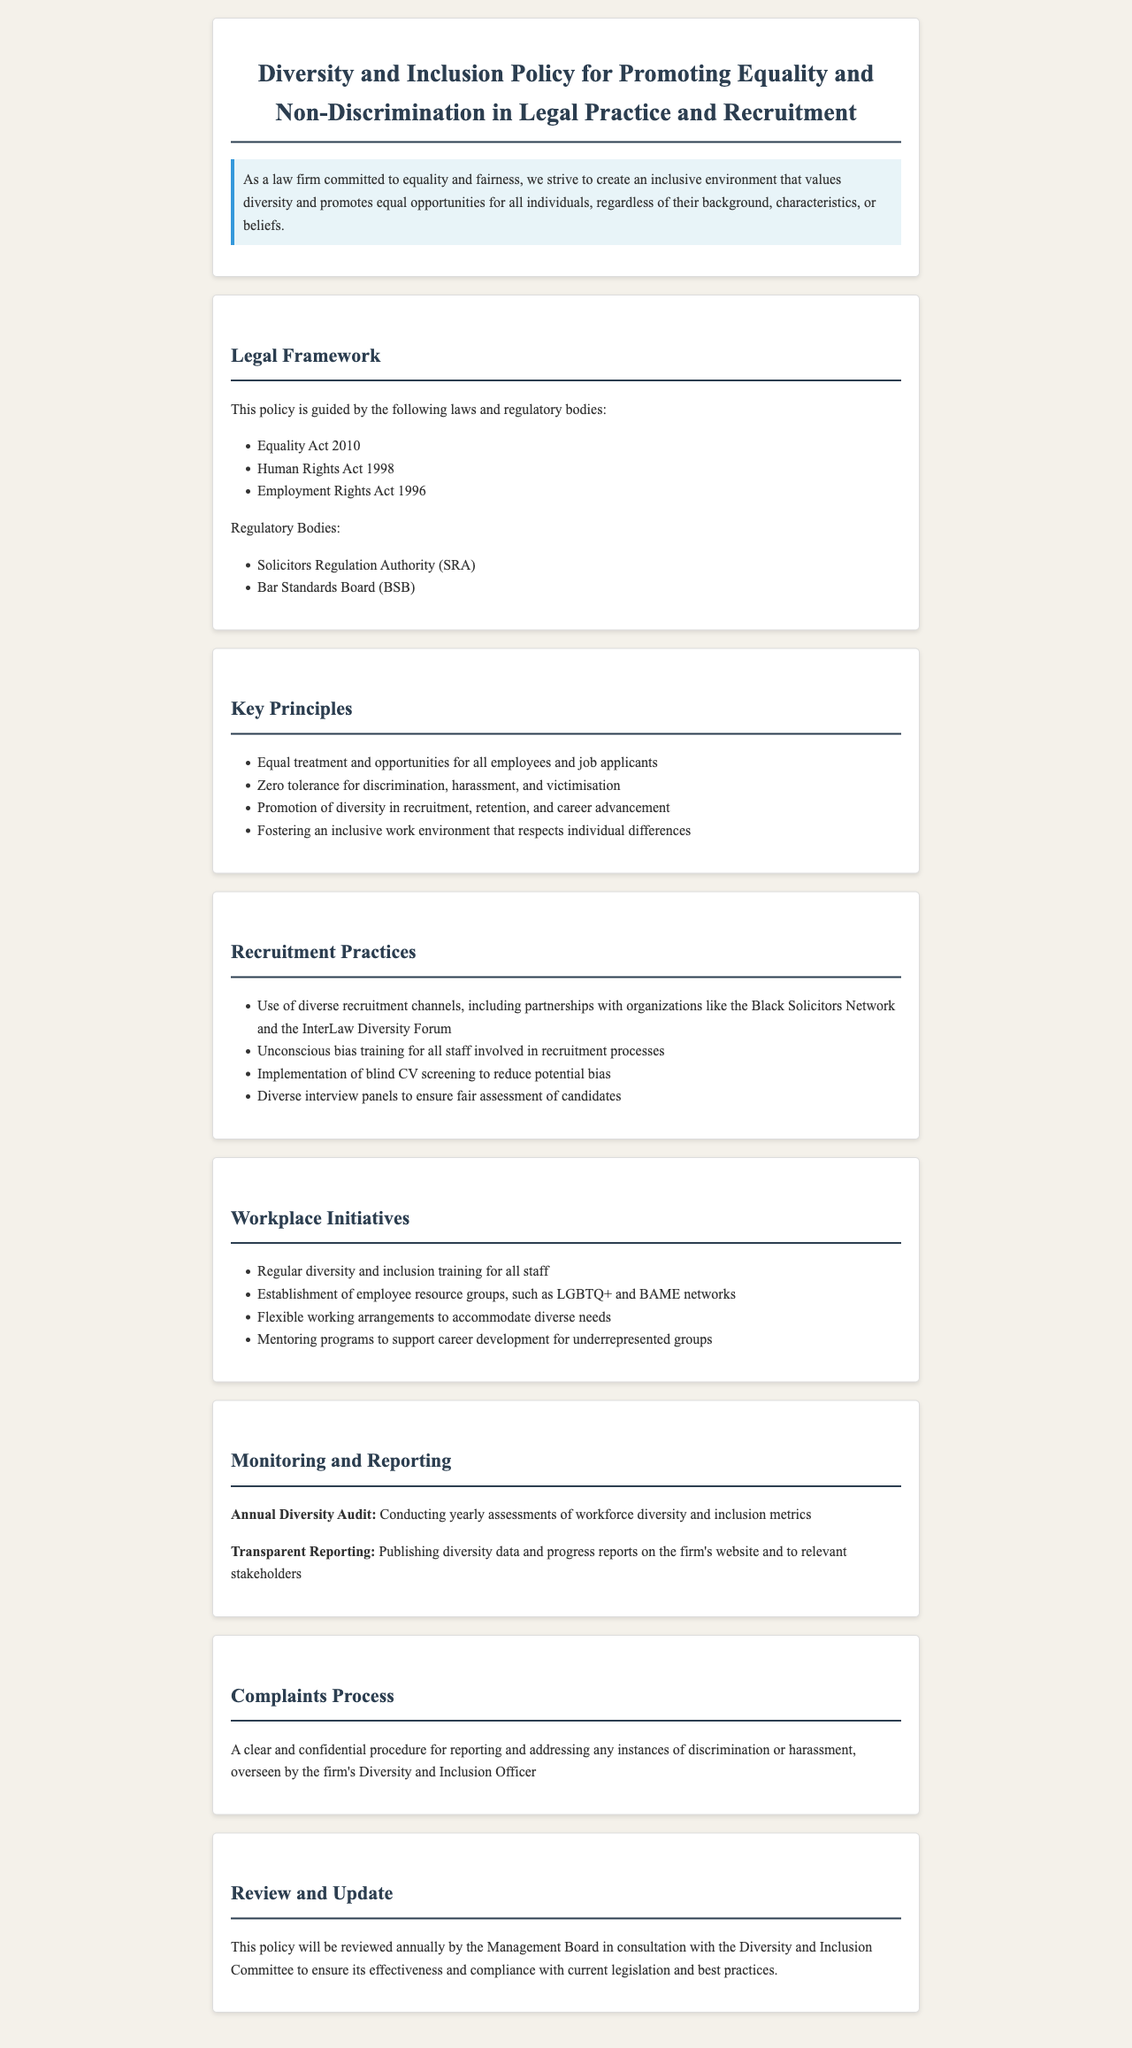What is the title of the policy? The title of the policy outlines its main focus on diversity and inclusion in legal practice and recruitment.
Answer: Diversity and Inclusion Policy for Promoting Equality and Non-Discrimination in Legal Practice and Recruitment Which act is included in the legal framework? This asks for a specific act that supports the policy’s legal background, mentioned under the Legal Framework section.
Answer: Equality Act 2010 What is the zero tolerance policy about? This refers to the principle that emphasizes a firm stance against specific negative behaviors within the workplace as stated in the Key Principles section.
Answer: Discrimination, harassment, and victimisation What recruitment practice is used to reduce potential bias? This question seeks a specific method mentioned in the Recruitment Practices section aimed at enhancing fairness during recruitment.
Answer: Blind CV screening What are the employee resource groups mentioned? This question looks for specific types of support networks highlighted in the Workplace Initiatives section that promote diversity.
Answer: LGBTQ+ and BAME networks How often will the policy be reviewed? This question addresses the frequency of the policy's review as outlined in the Review and Update section of the document.
Answer: Annually Who oversees the complaints process? This looks for the role or title responsible for managing the complaints process mentioned in the Complaints Process section of the document.
Answer: Diversity and Inclusion Officer What is conducted yearly to assess diversity metrics? This question refers to a specific activity mentioned in the Monitoring and Reporting section that focuses on reviewing diversity within the firm.
Answer: Annual Diversity Audit 